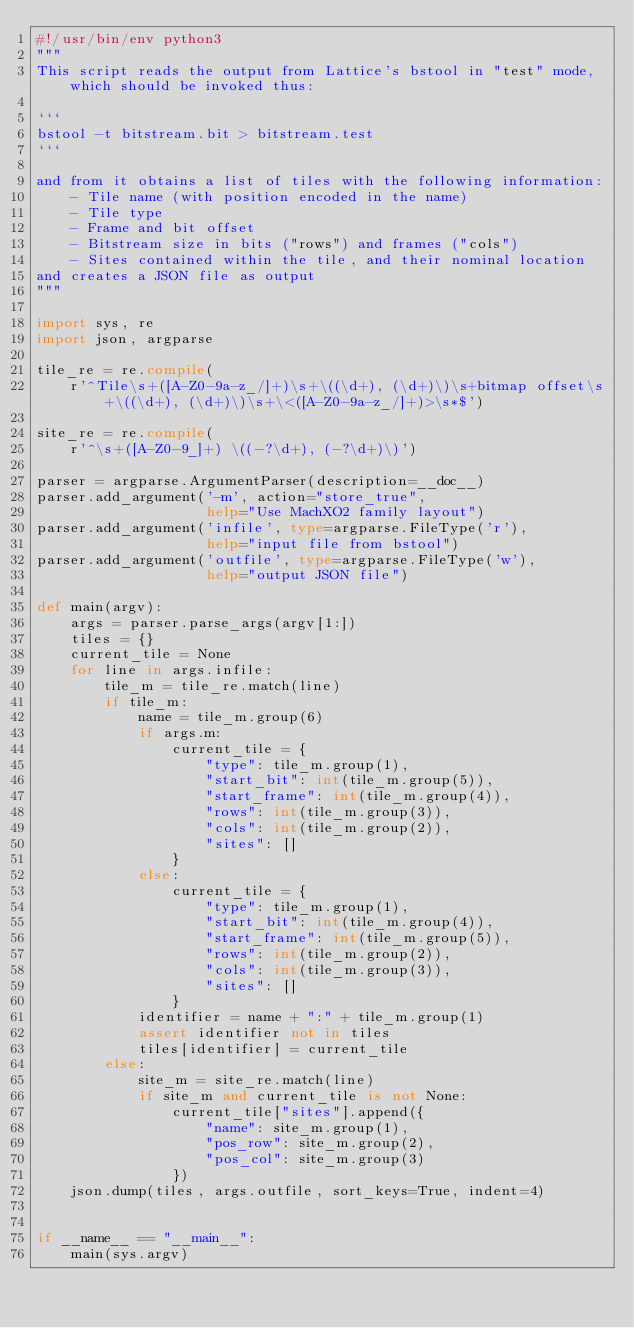<code> <loc_0><loc_0><loc_500><loc_500><_Python_>#!/usr/bin/env python3
"""
This script reads the output from Lattice's bstool in "test" mode, which should be invoked thus:

```
bstool -t bitstream.bit > bitstream.test
```

and from it obtains a list of tiles with the following information:
    - Tile name (with position encoded in the name)
    - Tile type
    - Frame and bit offset
    - Bitstream size in bits ("rows") and frames ("cols")
    - Sites contained within the tile, and their nominal location
and creates a JSON file as output
"""

import sys, re
import json, argparse

tile_re = re.compile(
    r'^Tile\s+([A-Z0-9a-z_/]+)\s+\((\d+), (\d+)\)\s+bitmap offset\s+\((\d+), (\d+)\)\s+\<([A-Z0-9a-z_/]+)>\s*$')

site_re = re.compile(
    r'^\s+([A-Z0-9_]+) \((-?\d+), (-?\d+)\)')

parser = argparse.ArgumentParser(description=__doc__)
parser.add_argument('-m', action="store_true",
                    help="Use MachXO2 family layout")
parser.add_argument('infile', type=argparse.FileType('r'),
                    help="input file from bstool")
parser.add_argument('outfile', type=argparse.FileType('w'),
                    help="output JSON file")

def main(argv):
    args = parser.parse_args(argv[1:])
    tiles = {}
    current_tile = None
    for line in args.infile:
        tile_m = tile_re.match(line)
        if tile_m:
            name = tile_m.group(6)
            if args.m:
                current_tile = {
                    "type": tile_m.group(1),
                    "start_bit": int(tile_m.group(5)),
                    "start_frame": int(tile_m.group(4)),
                    "rows": int(tile_m.group(3)),
                    "cols": int(tile_m.group(2)),
                    "sites": []
                }
            else:
                current_tile = {
                    "type": tile_m.group(1),
                    "start_bit": int(tile_m.group(4)),
                    "start_frame": int(tile_m.group(5)),
                    "rows": int(tile_m.group(2)),
                    "cols": int(tile_m.group(3)),
                    "sites": []
                }
            identifier = name + ":" + tile_m.group(1)
            assert identifier not in tiles
            tiles[identifier] = current_tile
        else:
            site_m = site_re.match(line)
            if site_m and current_tile is not None:
                current_tile["sites"].append({
                    "name": site_m.group(1),
                    "pos_row": site_m.group(2),
                    "pos_col": site_m.group(3)
                })
    json.dump(tiles, args.outfile, sort_keys=True, indent=4)


if __name__ == "__main__":
    main(sys.argv)
</code> 